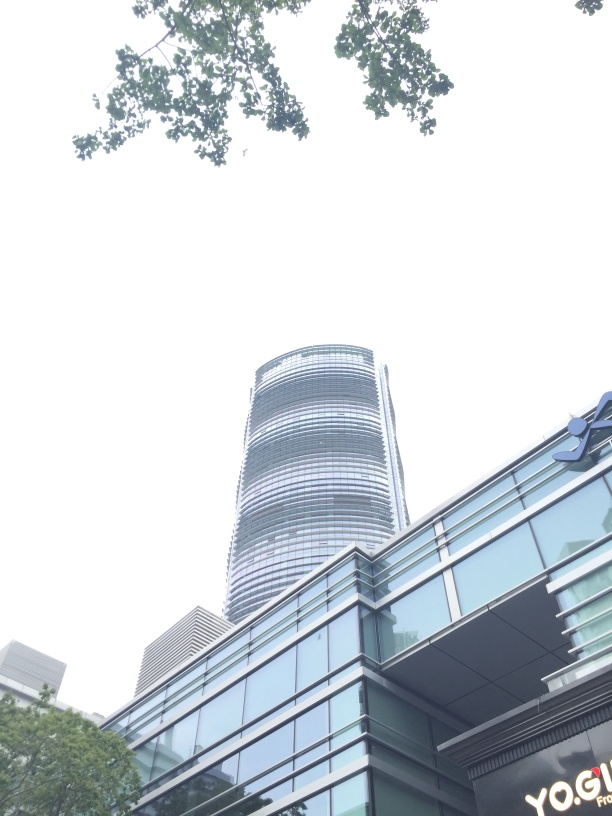What would be the best time of day to photograph this building for optimal natural lighting? The optimal time for photographing the building would be during the golden hour, which occurs shortly after sunrise or before sunset. The angled sunlight would accentuate the building's features and create a warm, inviting glow. 